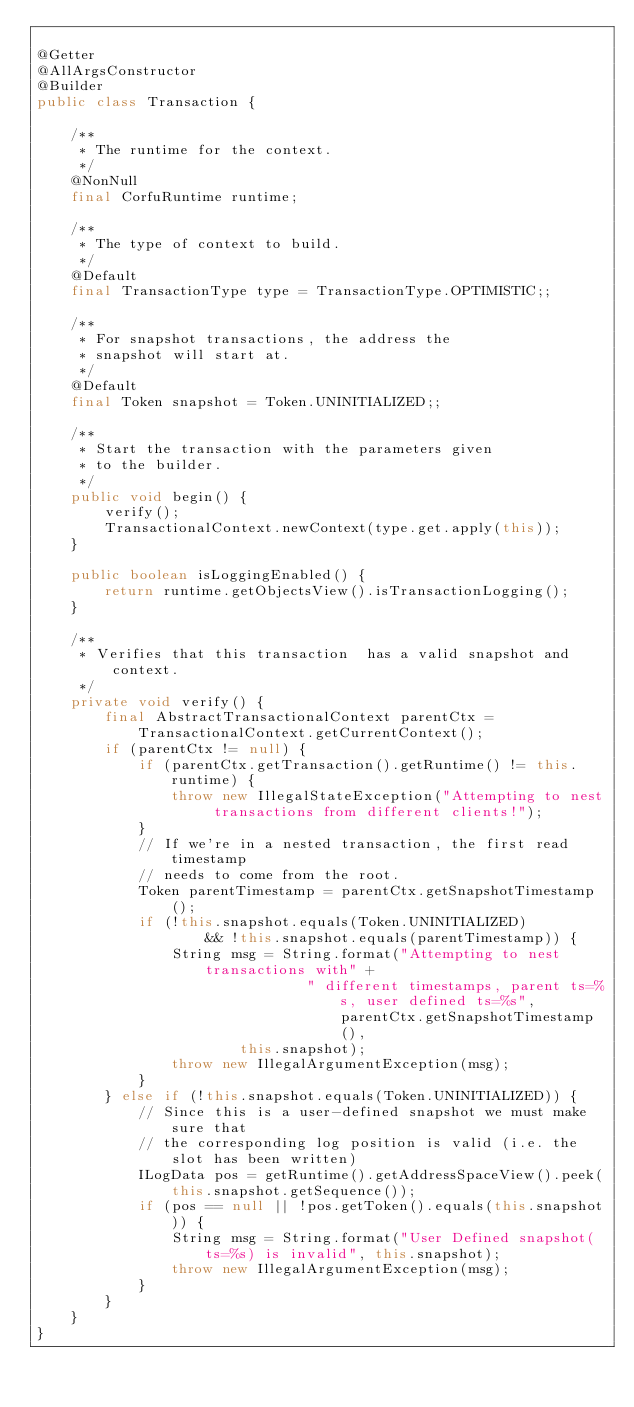<code> <loc_0><loc_0><loc_500><loc_500><_Java_>
@Getter
@AllArgsConstructor
@Builder
public class Transaction {

    /**
     * The runtime for the context.
     */
    @NonNull
    final CorfuRuntime runtime;

    /**
     * The type of context to build.
     */
    @Default
    final TransactionType type = TransactionType.OPTIMISTIC;;

    /**
     * For snapshot transactions, the address the
     * snapshot will start at.
     */
    @Default
    final Token snapshot = Token.UNINITIALIZED;;

    /**
     * Start the transaction with the parameters given
     * to the builder.
     */
    public void begin() {
        verify();
        TransactionalContext.newContext(type.get.apply(this));
    }

    public boolean isLoggingEnabled() {
        return runtime.getObjectsView().isTransactionLogging();
    }

    /**
     * Verifies that this transaction  has a valid snapshot and context.
     */
    private void verify() {
        final AbstractTransactionalContext parentCtx = TransactionalContext.getCurrentContext();
        if (parentCtx != null) {
            if (parentCtx.getTransaction().getRuntime() != this.runtime) {
                throw new IllegalStateException("Attempting to nest transactions from different clients!");
            }
            // If we're in a nested transaction, the first read timestamp
            // needs to come from the root.
            Token parentTimestamp = parentCtx.getSnapshotTimestamp();
            if (!this.snapshot.equals(Token.UNINITIALIZED)
                    && !this.snapshot.equals(parentTimestamp)) {
                String msg = String.format("Attempting to nest transactions with" +
                                " different timestamps, parent ts=%s, user defined ts=%s", parentCtx.getSnapshotTimestamp(),
                        this.snapshot);
                throw new IllegalArgumentException(msg);
            }
        } else if (!this.snapshot.equals(Token.UNINITIALIZED)) {
            // Since this is a user-defined snapshot we must make sure that
            // the corresponding log position is valid (i.e. the slot has been written)
            ILogData pos = getRuntime().getAddressSpaceView().peek(this.snapshot.getSequence());
            if (pos == null || !pos.getToken().equals(this.snapshot)) {
                String msg = String.format("User Defined snapshot(ts=%s) is invalid", this.snapshot);
                throw new IllegalArgumentException(msg);
            }
        }
    }
}
</code> 